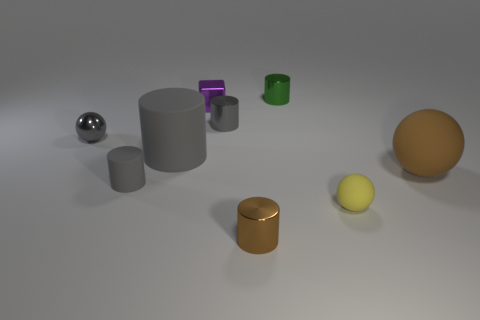Subtract all cyan blocks. How many gray cylinders are left? 3 Subtract all brown cylinders. How many cylinders are left? 4 Subtract all green shiny cylinders. How many cylinders are left? 4 Subtract all purple spheres. Subtract all red cubes. How many spheres are left? 3 Subtract all cylinders. How many objects are left? 4 Add 5 large blue matte blocks. How many large blue matte blocks exist? 5 Subtract 0 blue blocks. How many objects are left? 9 Subtract all matte balls. Subtract all small shiny things. How many objects are left? 2 Add 8 small green shiny cylinders. How many small green shiny cylinders are left? 9 